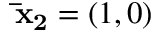<formula> <loc_0><loc_0><loc_500><loc_500>\bar { x } _ { 2 } = ( 1 , 0 )</formula> 